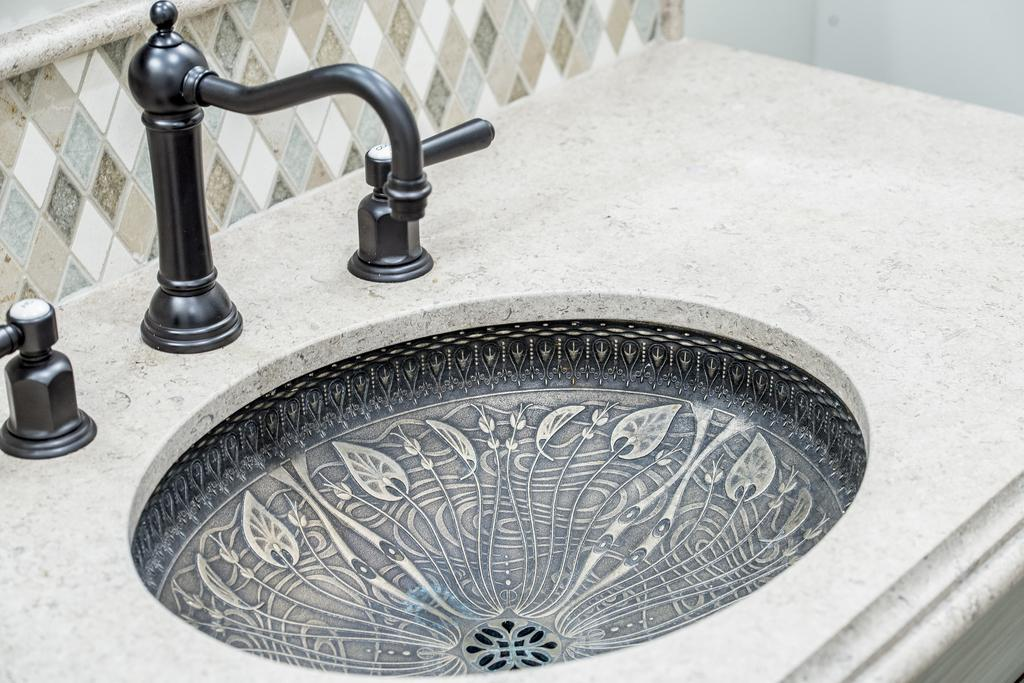What is the main object in the image? There is a basin in the image. What is attached to the basin? There is a water tap in the image. How many dogs are sitting on the base in the image? There are no dogs or base present in the image. 